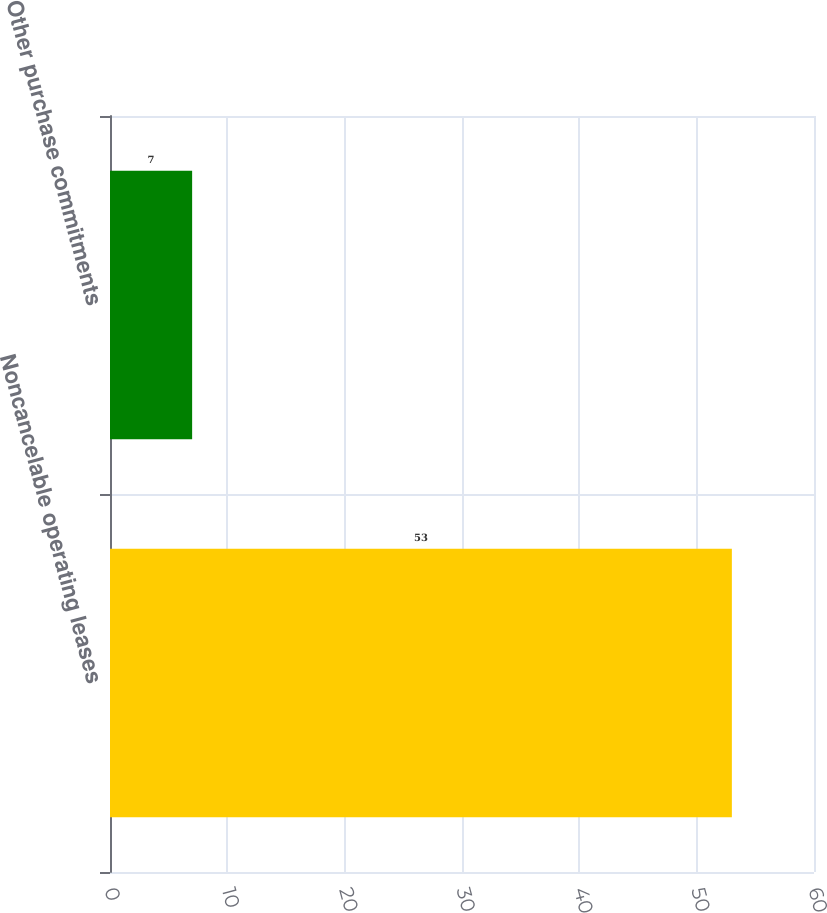<chart> <loc_0><loc_0><loc_500><loc_500><bar_chart><fcel>Noncancelable operating leases<fcel>Other purchase commitments<nl><fcel>53<fcel>7<nl></chart> 